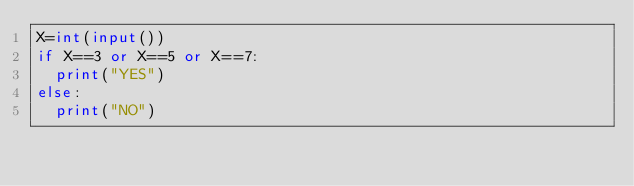<code> <loc_0><loc_0><loc_500><loc_500><_Python_>X=int(input())
if X==3 or X==5 or X==7:
  print("YES")
else:
  print("NO")
</code> 